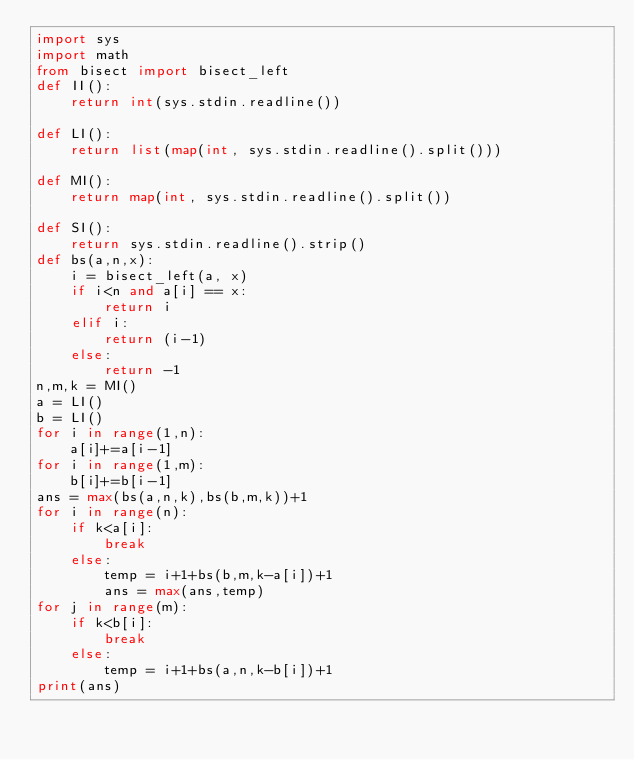<code> <loc_0><loc_0><loc_500><loc_500><_Python_>import sys
import math
from bisect import bisect_left
def II():
	return int(sys.stdin.readline())

def LI():
	return list(map(int, sys.stdin.readline().split()))

def MI():
	return map(int, sys.stdin.readline().split())

def SI():
	return sys.stdin.readline().strip()
def bs(a,n,x): 
    i = bisect_left(a, x) 
    if i<n and a[i] == x:
    	return i
    elif i:
    	return (i-1) 
    else: 
        return -1
n,m,k = MI()
a = LI()
b = LI()
for i in range(1,n):
	a[i]+=a[i-1]
for i in range(1,m):
	b[i]+=b[i-1]
ans = max(bs(a,n,k),bs(b,m,k))+1
for i in range(n):
	if k<a[i]:
		break
	else:
		temp = i+1+bs(b,m,k-a[i])+1
		ans = max(ans,temp)
for j in range(m):
	if k<b[i]:
		break
	else:
		temp = i+1+bs(a,n,k-b[i])+1
print(ans)

</code> 